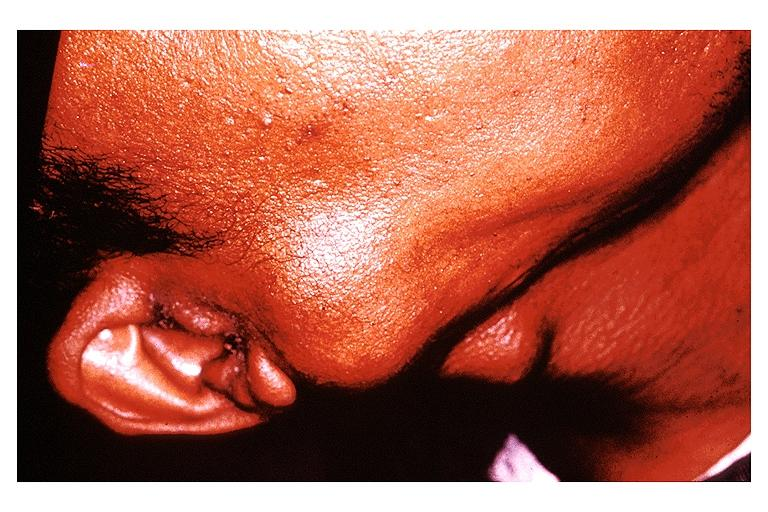s blood present?
Answer the question using a single word or phrase. No 